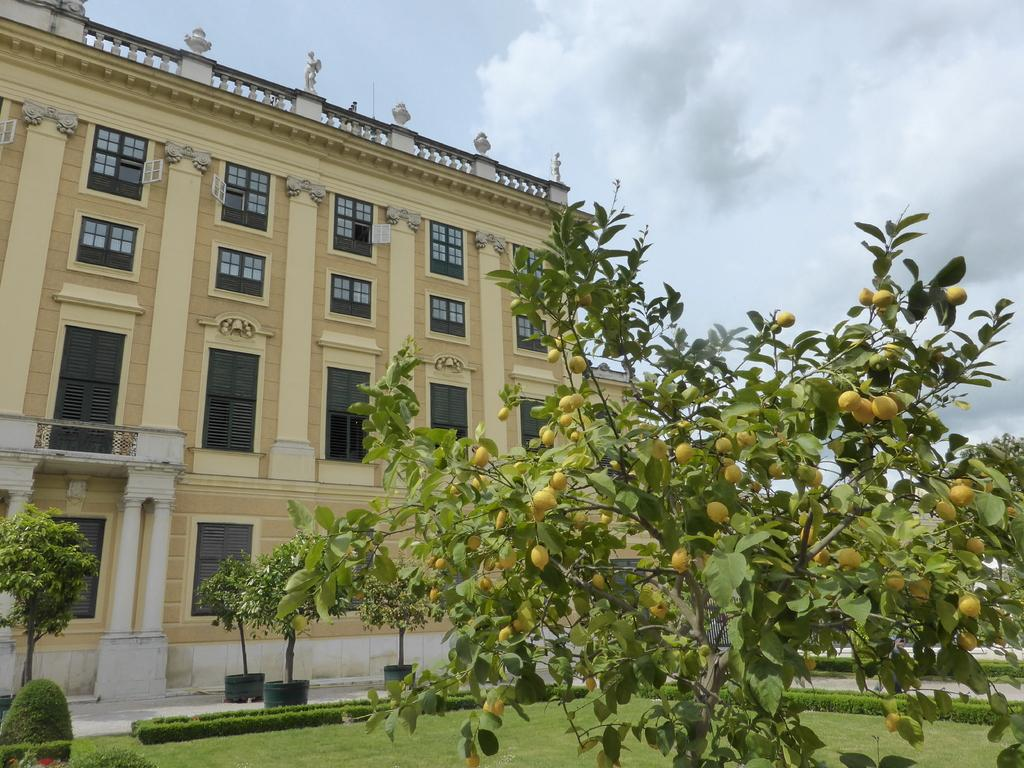What type of tree is present in the image? There is a lemon tree in the image. What can be found on the lemon tree? The lemon tree has lemons on it. What other types of vegetation are in the image? There are bushes, plants, and trees in the image. What structure can be seen in the image? There is a building in the image. What is visible in the sky in the image? There are clouds in the sky in the image. Where is the worm located in the image? There is no worm present in the image. What is the purpose of the basin in the image? There is no basin present in the image. 